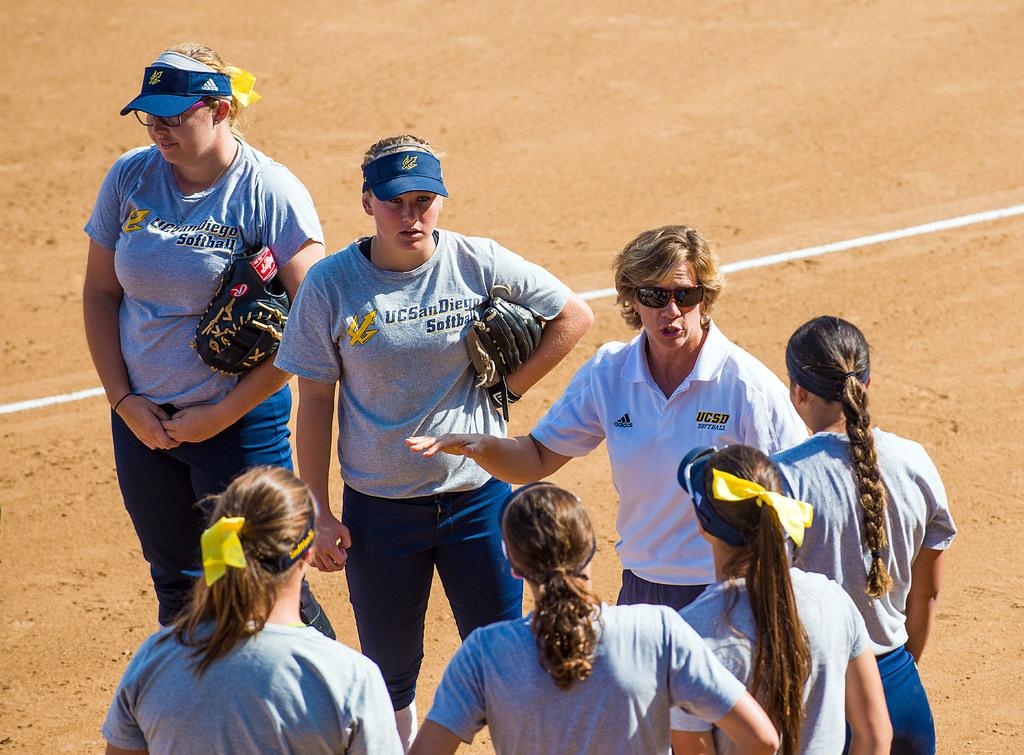How many people are in the image? There are people in the image. What is visible beneath the people in the image? There is ground visible in the image. What items are being held by two of the people in the image? Two people are holding gloves in the image. What protective gear is being worn by one of the people in the image? One person is wearing goggles in the image. Is the ground in the image actually quicksand? No, the ground in the image is not quicksand; it appears to be solid ground. Can you see a sail in the image? No, there is no sail present in the image. 